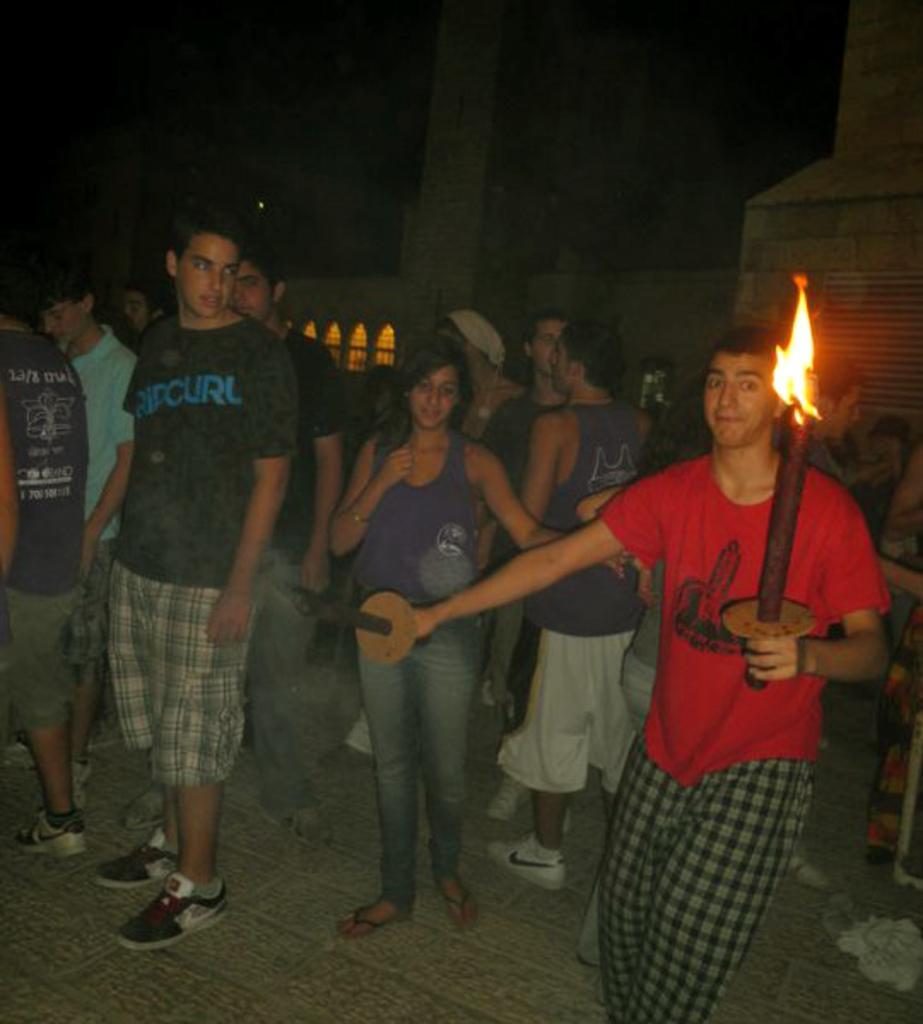Describe this image in one or two sentences. In this image I can see there are persons standing. And one person is holding an object and a fire lamp. And at the back there is a building. 